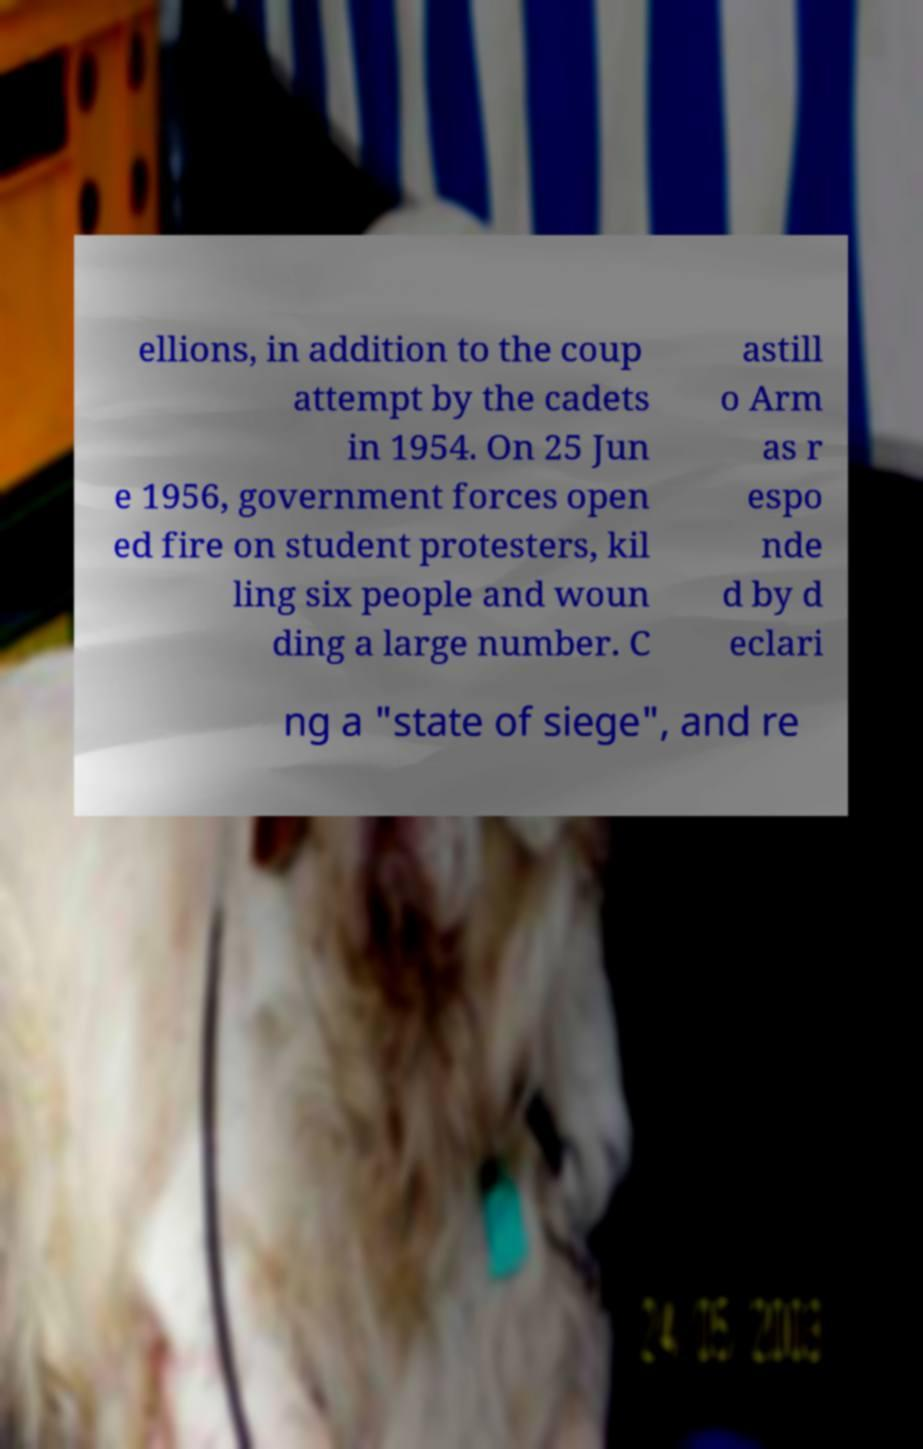Please identify and transcribe the text found in this image. ellions, in addition to the coup attempt by the cadets in 1954. On 25 Jun e 1956, government forces open ed fire on student protesters, kil ling six people and woun ding a large number. C astill o Arm as r espo nde d by d eclari ng a "state of siege", and re 